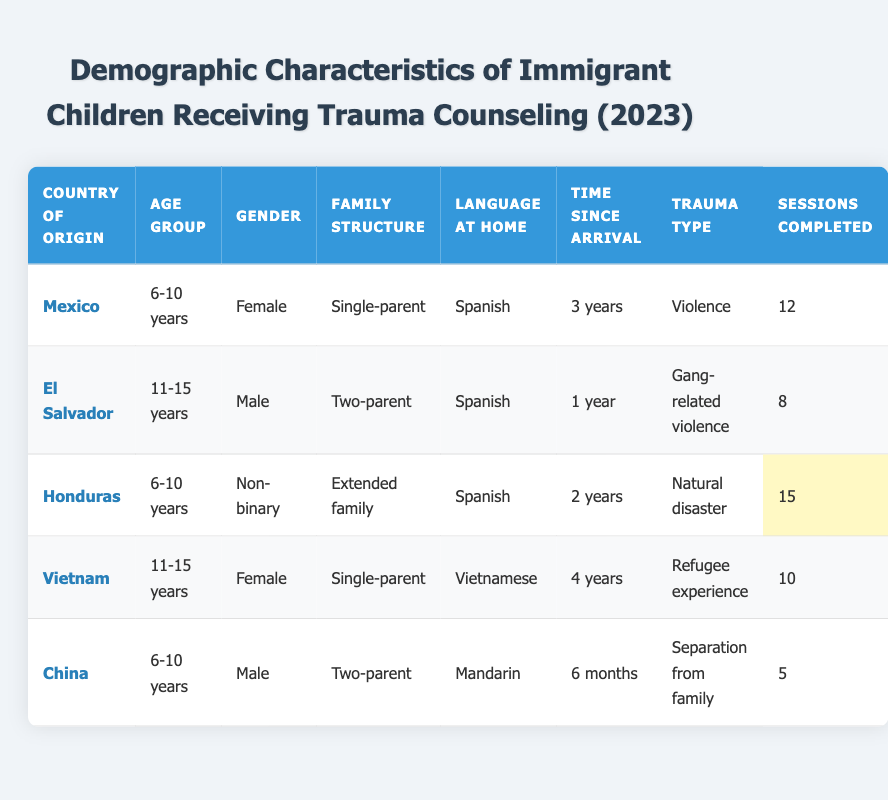What's the most common language spoken at home among the immigrant children? The table indicates that all the children except for the ones from Vietnam and China speak Spanish at home. Therefore, Spanish is the most common language among immigrant children receiving trauma counseling.
Answer: Spanish How many counseling sessions did the non-binary child complete? In the row for the child from Honduras, it states that the non-binary child completed 15 counseling sessions.
Answer: 15 Is there a child who has been in the country for less than one year? The table lists the child from China who has been in the country for 6 months, which is less than one year.
Answer: Yes What is the average number of counseling sessions completed by children from a single-parent family structure? The children from single-parent families are from Mexico (12 sessions) and Vietnam (10 sessions). Their total sessions are 12 + 10 = 22. There are 2 children, so the average is 22/2 = 11.
Answer: 11 How many different trauma types are represented in the table? The table lists the following trauma types: Violence, Gang-related violence, Natural disaster, Refugee experience, and Separation from family. Therefore, there are 5 different trauma types represented.
Answer: 5 What is the duration after arrival of the child with the highest counseling sessions completed? The child from Honduras, who is non-binary, has the highest counseling sessions completed at 15, and their duration after arrival is 2 years.
Answer: 2 years Are there any children who have completed less than 10 counseling sessions? The table shows that the child from China completed only 5 counseling sessions, which is less than 10.
Answer: Yes Which age group has the highest number of sessions completed on average? The age group 6-10 years has completed the following sessions: 12 (Mexico) + 15 (Honduras) + 5 (China) = 32 sessions. There are 3 children in this group, so the average is 32/3 = approximately 10.67. The age group 11-15 years has: 8 (El Salvador) + 10 (Vietnam) = 18 sessions, with 2 children resulting in an average of 9. This shows that the 6-10 years group has a higher average.
Answer: 6-10 years 